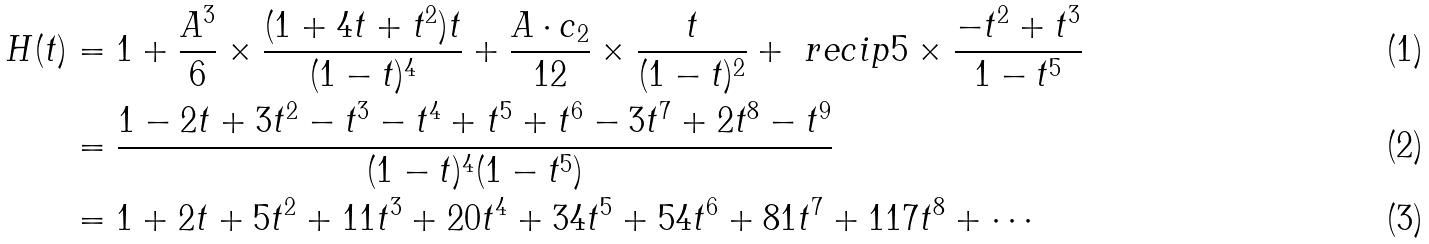Convert formula to latex. <formula><loc_0><loc_0><loc_500><loc_500>H ( t ) & = 1 + \frac { A ^ { 3 } } 6 \times \frac { ( 1 + 4 t + t ^ { 2 } ) t } { ( 1 - t ) ^ { 4 } } + \frac { A \cdot c _ { 2 } } { 1 2 } \times \frac { t } { ( 1 - t ) ^ { 2 } } + \ r e c i p 5 \times \frac { - t ^ { 2 } + t ^ { 3 } } { 1 - t ^ { 5 } } \\ & = \frac { 1 - 2 t + 3 t ^ { 2 } - t ^ { 3 } - t ^ { 4 } + t ^ { 5 } + t ^ { 6 } - 3 t ^ { 7 } + 2 t ^ { 8 } - t ^ { 9 } } { ( 1 - t ) ^ { 4 } ( 1 - t ^ { 5 } ) } \\ & = 1 + 2 t + 5 t ^ { 2 } + 1 1 t ^ { 3 } + 2 0 t ^ { 4 } + 3 4 t ^ { 5 } + 5 4 t ^ { 6 } + 8 1 t ^ { 7 } + 1 1 7 t ^ { 8 } + \cdots</formula> 